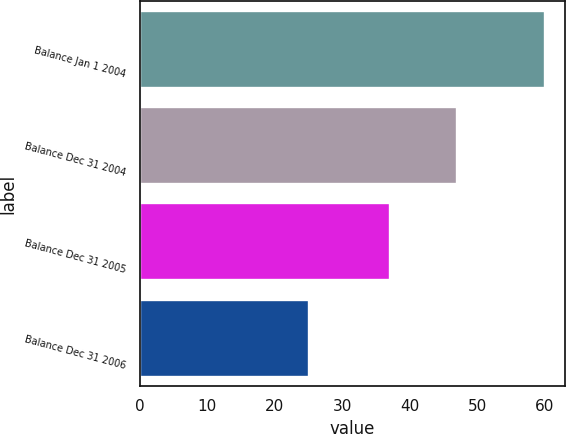Convert chart to OTSL. <chart><loc_0><loc_0><loc_500><loc_500><bar_chart><fcel>Balance Jan 1 2004<fcel>Balance Dec 31 2004<fcel>Balance Dec 31 2005<fcel>Balance Dec 31 2006<nl><fcel>60<fcel>47<fcel>37<fcel>25<nl></chart> 